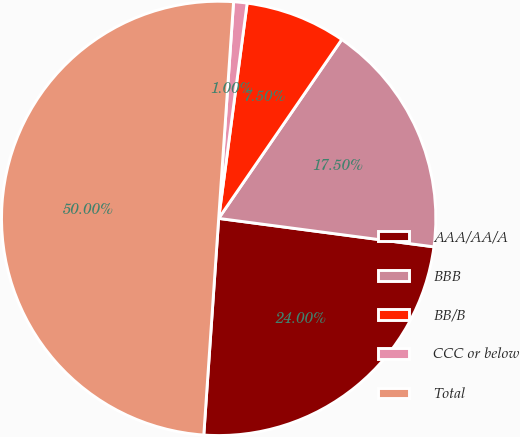Convert chart. <chart><loc_0><loc_0><loc_500><loc_500><pie_chart><fcel>AAA/AA/A<fcel>BBB<fcel>BB/B<fcel>CCC or below<fcel>Total<nl><fcel>24.0%<fcel>17.5%<fcel>7.5%<fcel>1.0%<fcel>50.0%<nl></chart> 